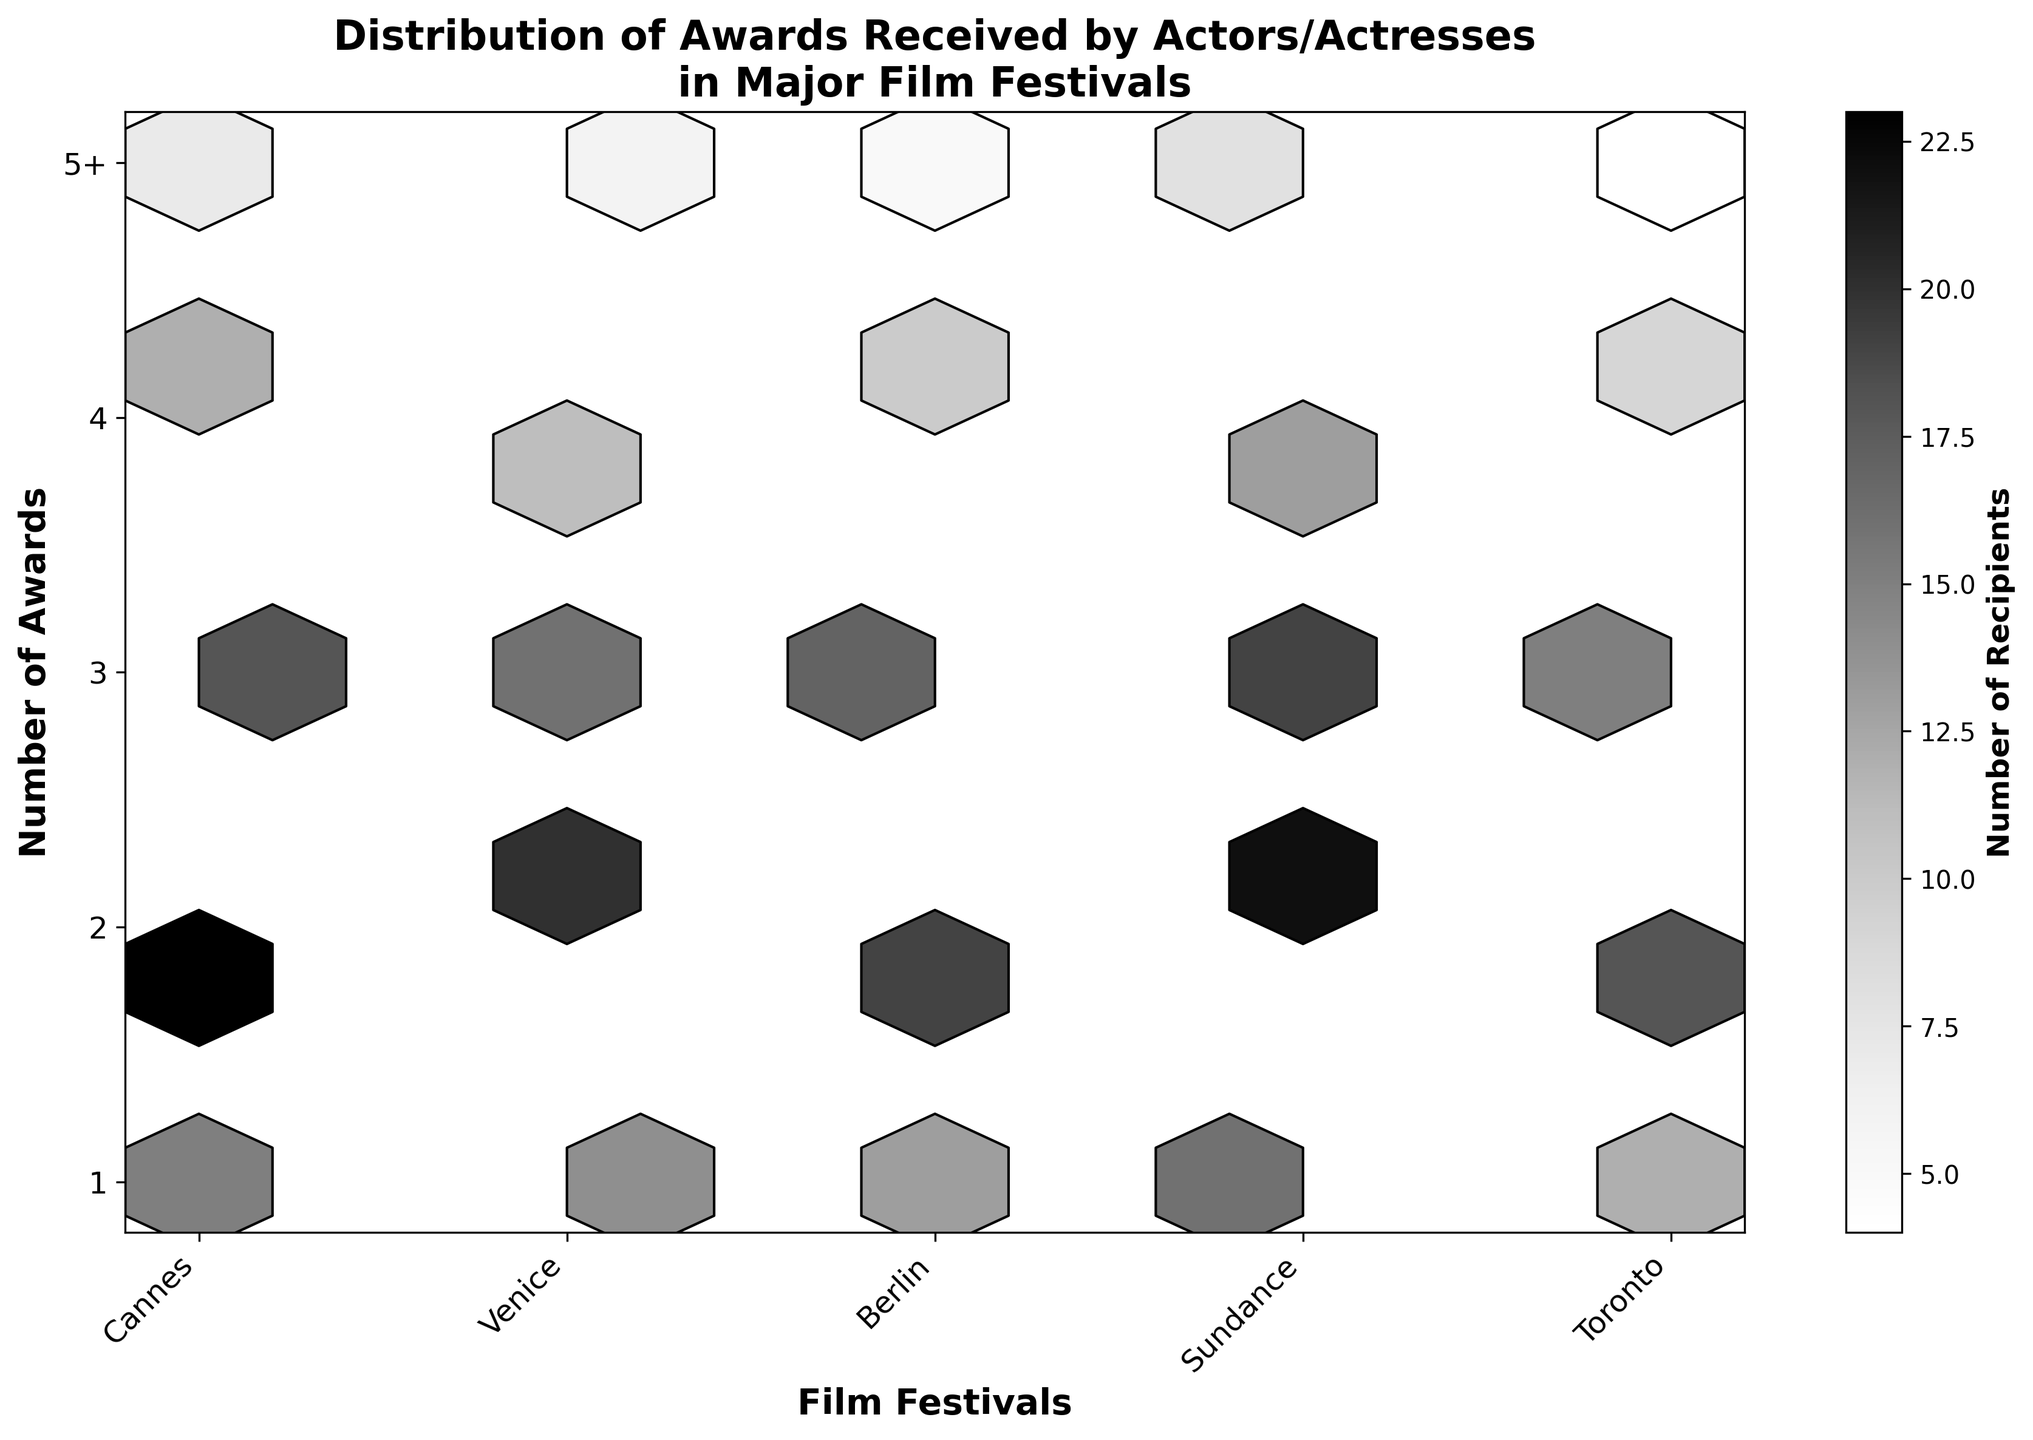What's the title of the plot? The title of the plot is displayed at the top center of the figure and is usually the most prominent text.
Answer: Distribution of Awards Received by Actors/Actresses in Major Film Festivals How many different film festivals are shown in the plot? The x-axis labels represent the film festivals in the plot, counting the number of unique labels will give the number of different film festivals.
Answer: 5 Which festival has the highest number of award recipients for the first award category? To find this, look at the top hexagons of each column and find the one with the largest shaded area, then check the x-axis label for the corresponding festival.
Answer: Cannes What is the median number of awards received across all festivals? To determine the median, note that the y-axis shows the number of awards. The median would be the middle value of the range (1 to 5), thus the middle value is 3.
Answer: 3 What is the color corresponding to the highest number of recipients in the colorbar? The colorbar indicates the number of recipients with varying shades from light to dark. The darkest shade represents the highest number.
Answer: Dark gray/Black Which festival shows the least variation in the number of awards received? Look for the festival with hexagons that are most uniformly shaded across the y-values. Less variation means less difference in the shade of the hexagons.
Answer: Berlin Which festival has the fewest recipients in the fifth award category? Check the hexagons in the fifth row (bottom row) for each festival and identify the lightest shaded one, then match it to the x-axis label.
Answer: Toronto Compare the number of recipients for three awards between Berlin and Toronto. Which festival has more? Sum the values for the y-axis values 3 for both Berlin and Toronto and compare them. Toronto has 15 and Berlin has 17. Therefore, Berlin has more.
Answer: Berlin Is there a clear pattern showing that one festival consistently awards more recipients than others? Examine the hexagons for each festival across the y-axis. Consistent awards would show as uniformly darker shades in one column compared to others but no single festival stands out this way.
Answer: No clear pattern 